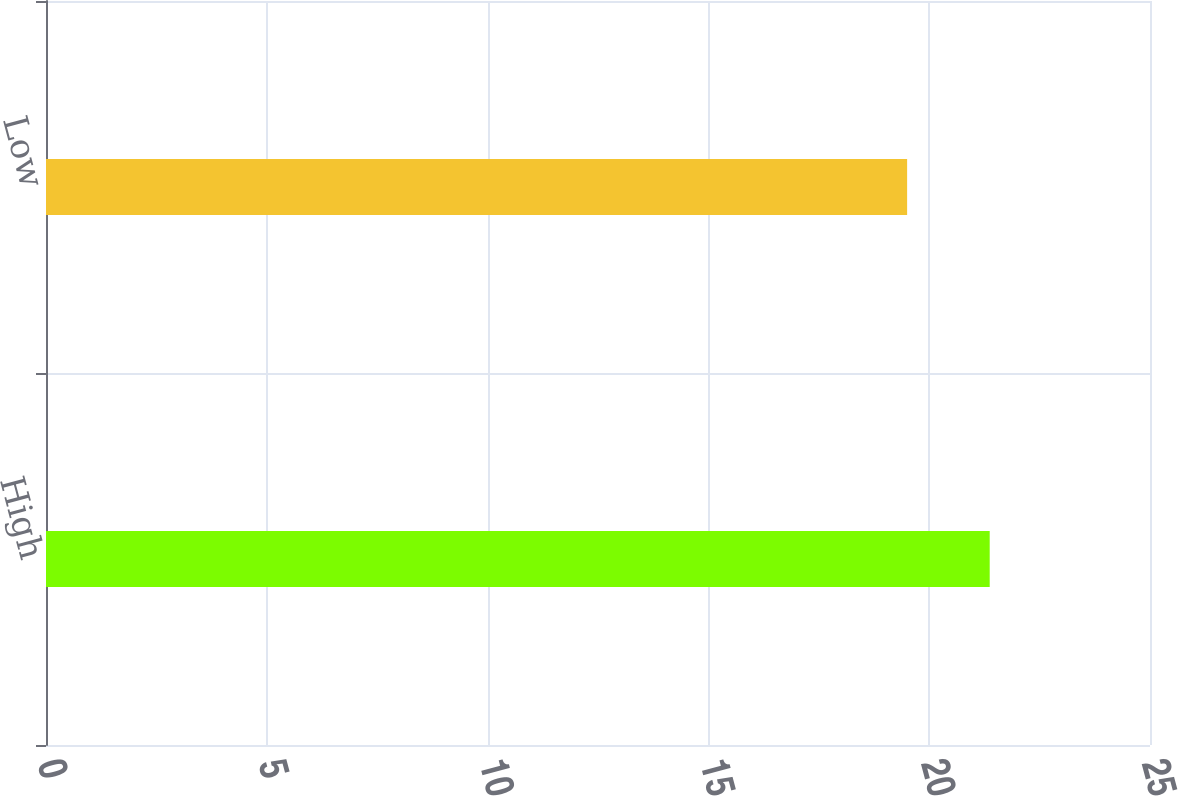<chart> <loc_0><loc_0><loc_500><loc_500><bar_chart><fcel>High<fcel>Low<nl><fcel>21.37<fcel>19.5<nl></chart> 